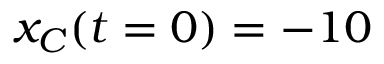Convert formula to latex. <formula><loc_0><loc_0><loc_500><loc_500>x _ { C } ( t = 0 ) = - 1 0</formula> 